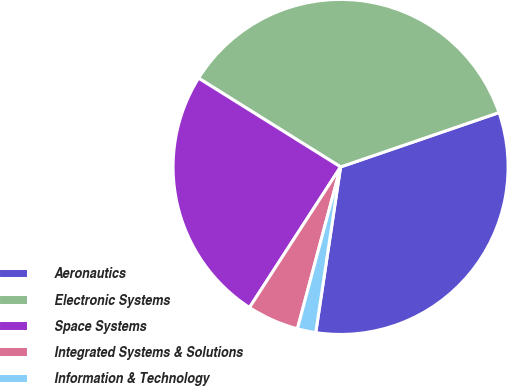Convert chart to OTSL. <chart><loc_0><loc_0><loc_500><loc_500><pie_chart><fcel>Aeronautics<fcel>Electronic Systems<fcel>Space Systems<fcel>Integrated Systems & Solutions<fcel>Information & Technology<nl><fcel>32.63%<fcel>35.85%<fcel>24.74%<fcel>5.0%<fcel>1.78%<nl></chart> 